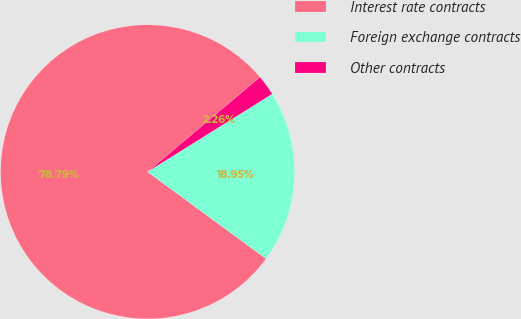Convert chart to OTSL. <chart><loc_0><loc_0><loc_500><loc_500><pie_chart><fcel>Interest rate contracts<fcel>Foreign exchange contracts<fcel>Other contracts<nl><fcel>78.78%<fcel>18.95%<fcel>2.26%<nl></chart> 